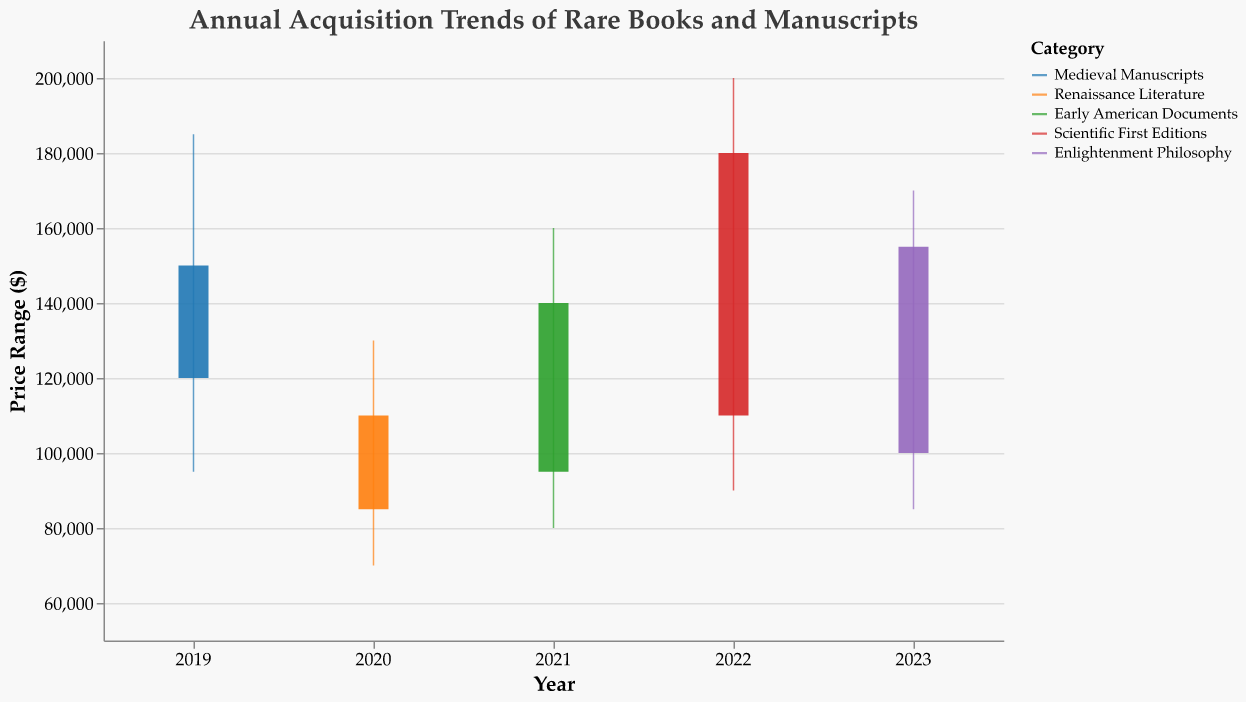What is the title of the chart? The title of the chart is displayed prominently at the top and reads: "Annual Acquisition Trends of Rare Books and Manuscripts".
Answer: Annual Acquisition Trends of Rare Books and Manuscripts What variable is plotted on the x-axis? The x-axis represents the years from 2019 to 2023, indicating different acquisition years.
Answer: Year Which subject category had the highest acquisition cost in 2022? By examining the figure for 2022, the highest point, or the maximum acquisition cost, is achieved by the "Scientific First Editions" category.
Answer: Scientific First Editions What is the price range of Medieval Manuscripts in 2019? By looking at the vertical span of the rule for 2019, the price range goes from the lowest point at $95,000 to the highest point at $185,000.
Answer: $95,000 to $185,000 How does the acquisition cost of Enlightenment Philosophy compare to Renaissance Literature in terms of the opening and closing prices? For 2023, Enlightenment Philosophy has an opening price of $100,000 and a closing price of $155,000. In 2020, Renaissance Literature has an opening price of $85,000 and a closing price of $110,000. Enlightenment Philosophy started higher and ended higher than Renaissance Literature.
Answer: Higher Which year showed the smallest range in acquisition costs? To determine the smallest range, subtract the lowest price from the highest price for each year. 2019: $185,000 - $95,000 = $90,000; 2020: $130,000 - $70,000 = $60,000; 2021: $160,000 - $80,000 = $80,000; 2022: $200,000 - $90,000 = $110,000; 2023: $170,000 - $85,000 = $85,000. The smallest range is in 2020 with $60,000.
Answer: 2020 Between the years 2019 and 2023, which category experienced the highest final acquisition price? Examine the closing price for each year: 2019: $150,000; 2020: $110,000; 2021: $140,000; 2022: $180,000; 2023: $155,000. Scientific First Editions in 2022 had the highest final acquisition price of $180,000.
Answer: 2022, Scientific First Editions What was the average closing price of rare books and manuscripts from 2019 to 2023? To find the average closing price, add up all the closing prices and divide by the number of years. (150,000 + 110,000 + 140,000 + 180,000 + 155,000) / 5 = 735,000 / 5 = $147,000.
Answer: $147,000 Which category had the most significant increase in acquisition cost by the end of the year compared to the start? Calculate the difference between the opening and closing price for each category: Medieval Manuscripts: $150,000 - $120,000 = $30,000; Renaissance Literature: $110,000 - $85,000 = $25,000; Early American Documents: $140,000 - $95,000 = $45,000; Scientific First Editions: $180,000 - $110,000 = $70,000; Enlightenment Philosophy: $155,000 - $100,000 = $55,000. Scientific First Editions had the most significant increase of $70,000.
Answer: Scientific First Editions What is the median high price within the dataset from 2019 to 2023? To find the median high price, list the high prices in ascending order: $130,000, $160,000, $170,000, $185,000, $200,000. The middle value is the third one: $170,000.
Answer: $170,000 